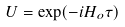<formula> <loc_0><loc_0><loc_500><loc_500>U = \exp ( - i H _ { o } \tau )</formula> 